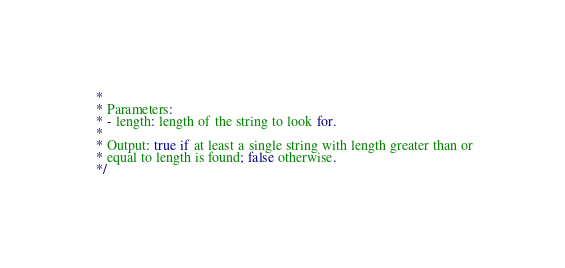Convert code to text. <code><loc_0><loc_0><loc_500><loc_500><_Java_> *
 * Parameters:
 * - length: length of the string to look for.
 *
 * Output: true if at least a single string with length greater than or
 * equal to length is found; false otherwise.
 */</code> 